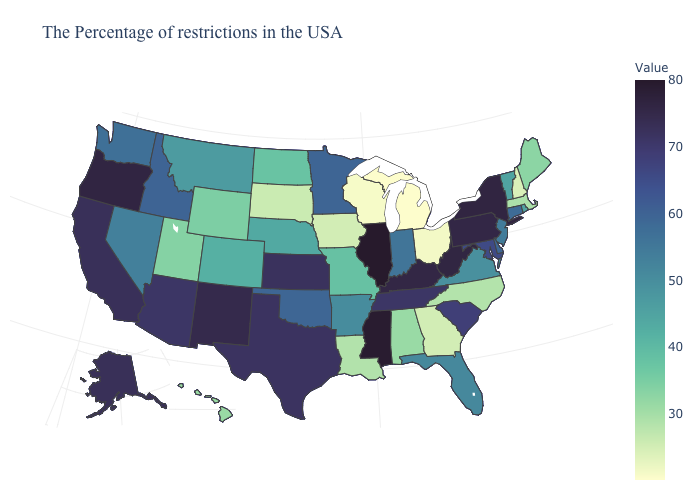Does Illinois have the highest value in the USA?
Short answer required. Yes. Does New York have the highest value in the Northeast?
Write a very short answer. Yes. Is the legend a continuous bar?
Keep it brief. Yes. Does Colorado have the lowest value in the USA?
Quick response, please. No. Which states hav the highest value in the West?
Short answer required. Oregon. 